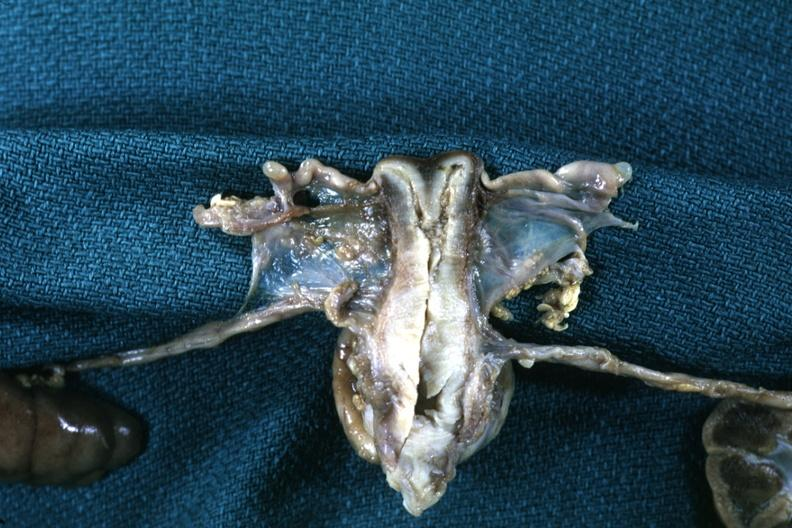does this image show fixed tissue frontal section through uterus with single fundus and two endocervical canals and cervical ossa?
Answer the question using a single word or phrase. Yes 